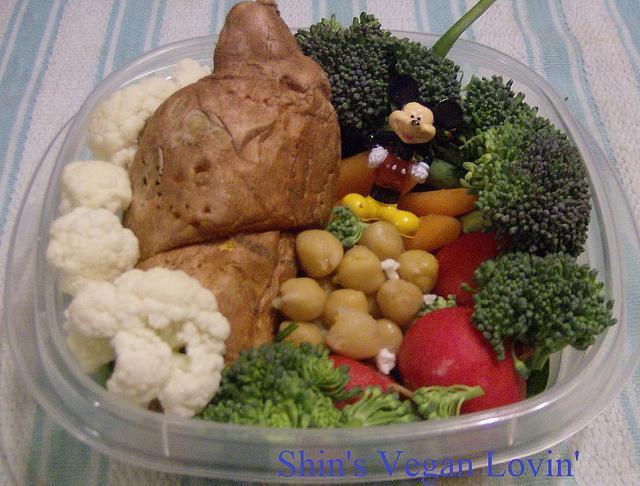How many broccolis are there?
Give a very brief answer. 2. How many bikes are there?
Give a very brief answer. 0. 